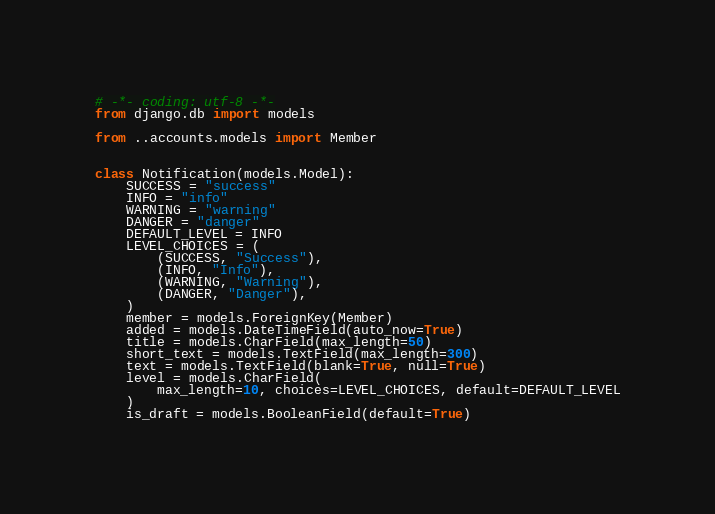<code> <loc_0><loc_0><loc_500><loc_500><_Python_># -*- coding: utf-8 -*-
from django.db import models

from ..accounts.models import Member


class Notification(models.Model):
    SUCCESS = "success"
    INFO = "info"
    WARNING = "warning"
    DANGER = "danger"
    DEFAULT_LEVEL = INFO
    LEVEL_CHOICES = (
        (SUCCESS, "Success"),
        (INFO, "Info"),
        (WARNING, "Warning"),
        (DANGER, "Danger"),
    )
    member = models.ForeignKey(Member)
    added = models.DateTimeField(auto_now=True)
    title = models.CharField(max_length=50)
    short_text = models.TextField(max_length=300)
    text = models.TextField(blank=True, null=True)
    level = models.CharField(
        max_length=10, choices=LEVEL_CHOICES, default=DEFAULT_LEVEL
    )
    is_draft = models.BooleanField(default=True)
</code> 